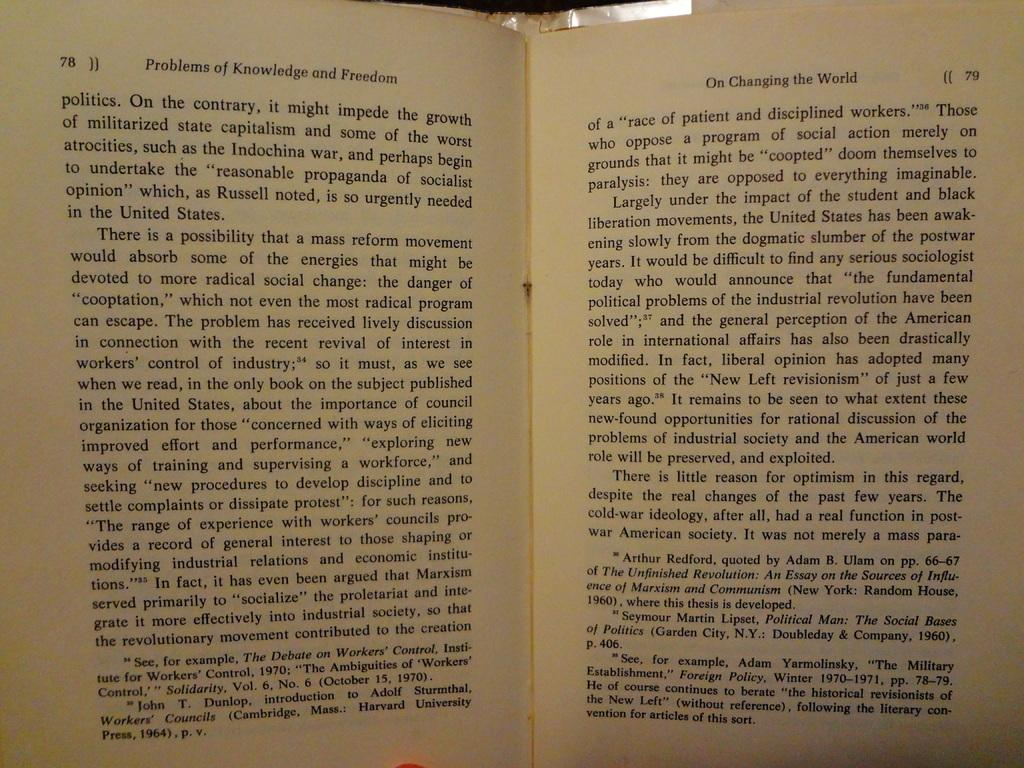<image>
Render a clear and concise summary of the photo. A book titled Problems of Knowledge and Freedom is open to pages 78 and 79. 